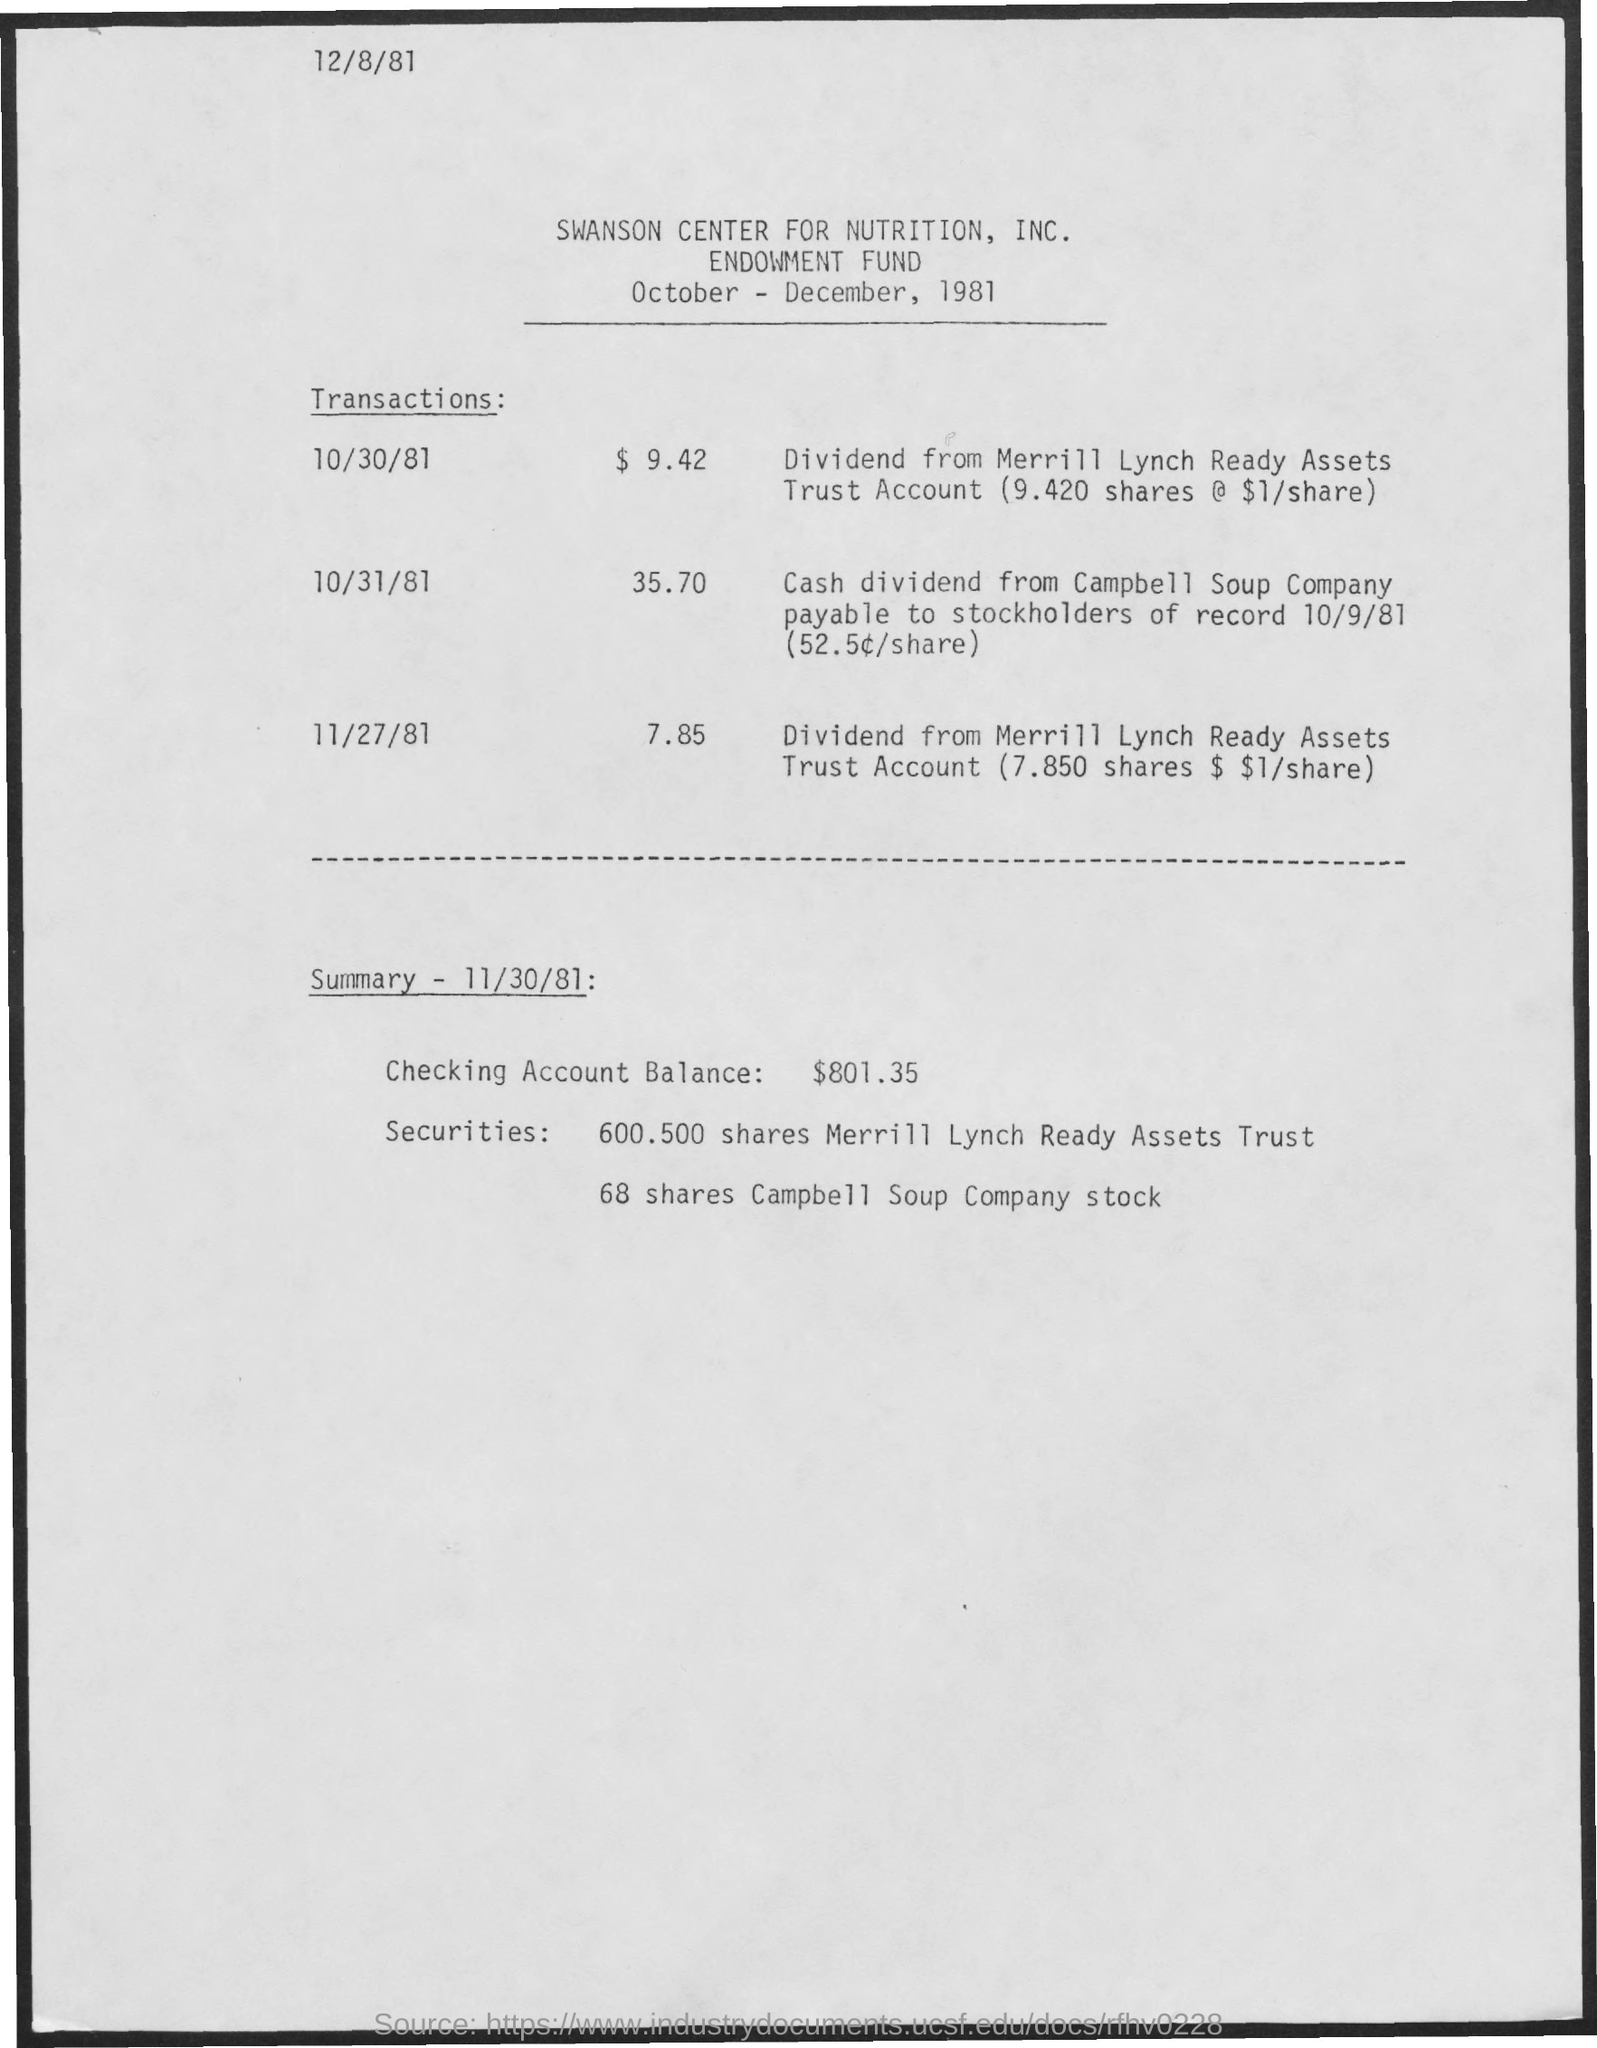What is the amount of transaction for 10/30/81?
Offer a very short reply. $9.42. What is the amount of transaction for 10/31/81?
Provide a short and direct response. 35.70. What is the amount of transaction for 11/27/81?
Make the answer very short. 7.85. What is the Checking Amount Balance?
Provide a succinct answer. $801.35. What are the securities for Merrill Lynch Ready Assets Trust?
Make the answer very short. 600.500 shares. What are the securities for Campbell Soup Company stock?
Give a very brief answer. 68 shares. 